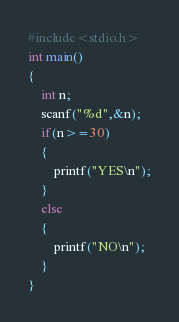<code> <loc_0><loc_0><loc_500><loc_500><_C_>#include<stdio.h>
int main()
{
    int n;
    scanf("%d",&n);
    if(n>=30)
    {
        printf("YES\n");
    }
    else
    {
        printf("NO\n");
    }
}</code> 